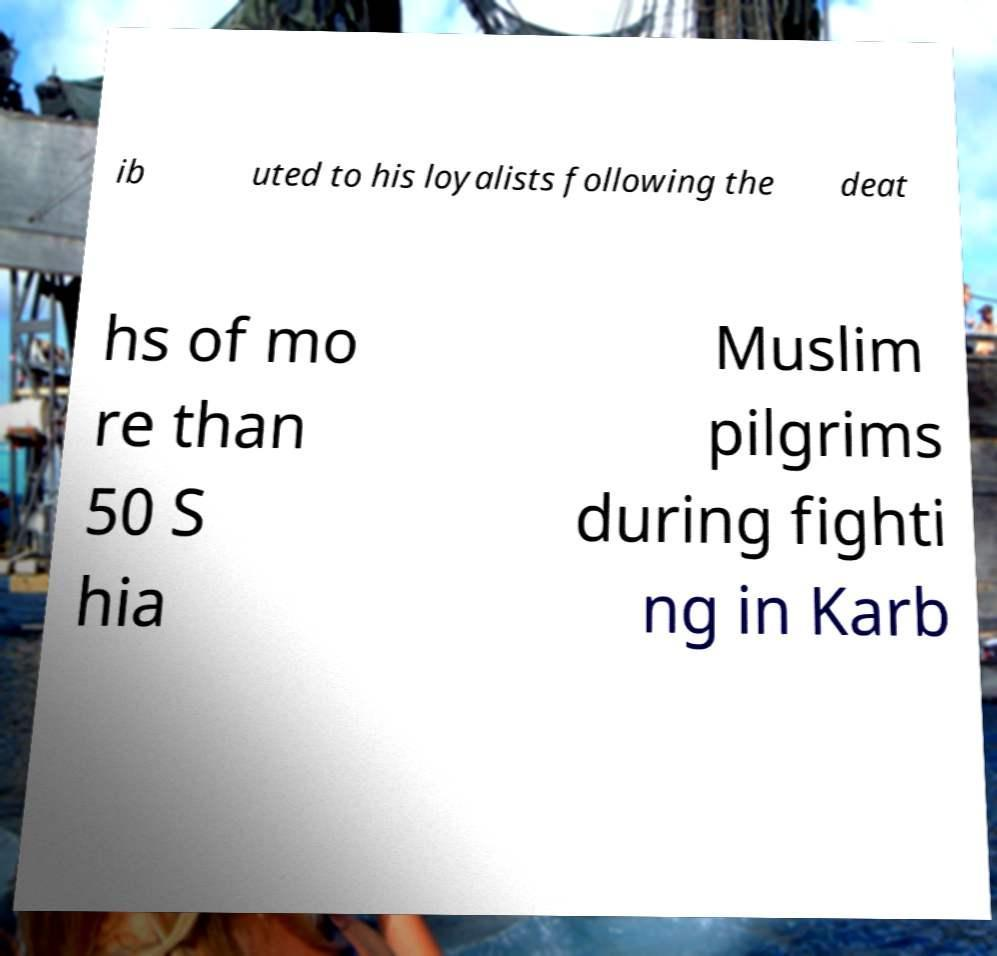Can you read and provide the text displayed in the image?This photo seems to have some interesting text. Can you extract and type it out for me? ib uted to his loyalists following the deat hs of mo re than 50 S hia Muslim pilgrims during fighti ng in Karb 